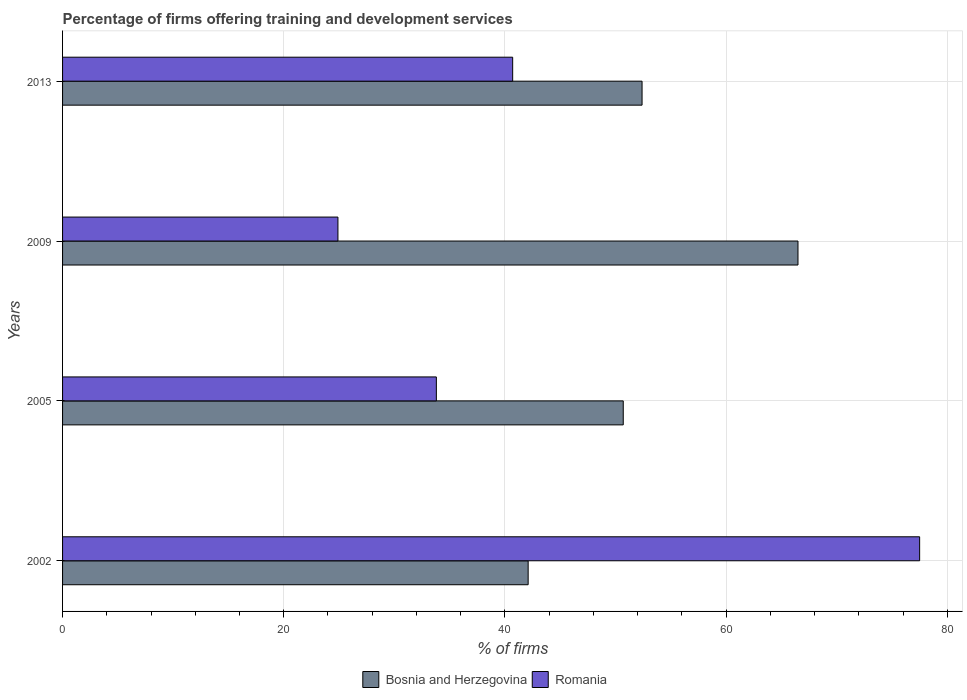Are the number of bars per tick equal to the number of legend labels?
Provide a succinct answer. Yes. Are the number of bars on each tick of the Y-axis equal?
Ensure brevity in your answer.  Yes. What is the label of the 4th group of bars from the top?
Keep it short and to the point. 2002. What is the percentage of firms offering training and development in Romania in 2005?
Your answer should be very brief. 33.8. Across all years, what is the maximum percentage of firms offering training and development in Bosnia and Herzegovina?
Provide a succinct answer. 66.5. Across all years, what is the minimum percentage of firms offering training and development in Bosnia and Herzegovina?
Your answer should be compact. 42.1. What is the total percentage of firms offering training and development in Romania in the graph?
Your answer should be very brief. 176.9. What is the difference between the percentage of firms offering training and development in Bosnia and Herzegovina in 2002 and that in 2013?
Offer a very short reply. -10.3. What is the difference between the percentage of firms offering training and development in Bosnia and Herzegovina in 2009 and the percentage of firms offering training and development in Romania in 2013?
Ensure brevity in your answer.  25.8. What is the average percentage of firms offering training and development in Romania per year?
Ensure brevity in your answer.  44.22. In the year 2002, what is the difference between the percentage of firms offering training and development in Bosnia and Herzegovina and percentage of firms offering training and development in Romania?
Your response must be concise. -35.4. In how many years, is the percentage of firms offering training and development in Romania greater than 56 %?
Ensure brevity in your answer.  1. What is the ratio of the percentage of firms offering training and development in Romania in 2009 to that in 2013?
Offer a terse response. 0.61. Is the percentage of firms offering training and development in Romania in 2009 less than that in 2013?
Provide a succinct answer. Yes. Is the difference between the percentage of firms offering training and development in Bosnia and Herzegovina in 2002 and 2009 greater than the difference between the percentage of firms offering training and development in Romania in 2002 and 2009?
Your response must be concise. No. What is the difference between the highest and the second highest percentage of firms offering training and development in Romania?
Give a very brief answer. 36.8. What is the difference between the highest and the lowest percentage of firms offering training and development in Romania?
Keep it short and to the point. 52.6. Is the sum of the percentage of firms offering training and development in Romania in 2005 and 2013 greater than the maximum percentage of firms offering training and development in Bosnia and Herzegovina across all years?
Make the answer very short. Yes. What does the 1st bar from the top in 2009 represents?
Give a very brief answer. Romania. What does the 1st bar from the bottom in 2009 represents?
Keep it short and to the point. Bosnia and Herzegovina. How many bars are there?
Provide a succinct answer. 8. How many years are there in the graph?
Provide a succinct answer. 4. Are the values on the major ticks of X-axis written in scientific E-notation?
Ensure brevity in your answer.  No. Where does the legend appear in the graph?
Provide a short and direct response. Bottom center. How many legend labels are there?
Offer a terse response. 2. What is the title of the graph?
Your answer should be very brief. Percentage of firms offering training and development services. Does "Zimbabwe" appear as one of the legend labels in the graph?
Your answer should be very brief. No. What is the label or title of the X-axis?
Offer a terse response. % of firms. What is the % of firms of Bosnia and Herzegovina in 2002?
Make the answer very short. 42.1. What is the % of firms of Romania in 2002?
Provide a succinct answer. 77.5. What is the % of firms of Bosnia and Herzegovina in 2005?
Offer a very short reply. 50.7. What is the % of firms of Romania in 2005?
Provide a short and direct response. 33.8. What is the % of firms of Bosnia and Herzegovina in 2009?
Offer a very short reply. 66.5. What is the % of firms of Romania in 2009?
Give a very brief answer. 24.9. What is the % of firms in Bosnia and Herzegovina in 2013?
Provide a succinct answer. 52.4. What is the % of firms of Romania in 2013?
Your response must be concise. 40.7. Across all years, what is the maximum % of firms in Bosnia and Herzegovina?
Your answer should be compact. 66.5. Across all years, what is the maximum % of firms of Romania?
Make the answer very short. 77.5. Across all years, what is the minimum % of firms of Bosnia and Herzegovina?
Provide a short and direct response. 42.1. Across all years, what is the minimum % of firms in Romania?
Your answer should be very brief. 24.9. What is the total % of firms in Bosnia and Herzegovina in the graph?
Provide a succinct answer. 211.7. What is the total % of firms of Romania in the graph?
Make the answer very short. 176.9. What is the difference between the % of firms of Romania in 2002 and that in 2005?
Keep it short and to the point. 43.7. What is the difference between the % of firms in Bosnia and Herzegovina in 2002 and that in 2009?
Provide a succinct answer. -24.4. What is the difference between the % of firms in Romania in 2002 and that in 2009?
Your answer should be very brief. 52.6. What is the difference between the % of firms in Bosnia and Herzegovina in 2002 and that in 2013?
Offer a terse response. -10.3. What is the difference between the % of firms of Romania in 2002 and that in 2013?
Offer a very short reply. 36.8. What is the difference between the % of firms of Bosnia and Herzegovina in 2005 and that in 2009?
Make the answer very short. -15.8. What is the difference between the % of firms of Bosnia and Herzegovina in 2005 and that in 2013?
Offer a very short reply. -1.7. What is the difference between the % of firms in Romania in 2005 and that in 2013?
Offer a terse response. -6.9. What is the difference between the % of firms in Bosnia and Herzegovina in 2009 and that in 2013?
Your answer should be compact. 14.1. What is the difference between the % of firms of Romania in 2009 and that in 2013?
Offer a terse response. -15.8. What is the difference between the % of firms of Bosnia and Herzegovina in 2002 and the % of firms of Romania in 2005?
Offer a very short reply. 8.3. What is the difference between the % of firms of Bosnia and Herzegovina in 2002 and the % of firms of Romania in 2009?
Your answer should be very brief. 17.2. What is the difference between the % of firms of Bosnia and Herzegovina in 2002 and the % of firms of Romania in 2013?
Give a very brief answer. 1.4. What is the difference between the % of firms of Bosnia and Herzegovina in 2005 and the % of firms of Romania in 2009?
Your answer should be very brief. 25.8. What is the difference between the % of firms in Bosnia and Herzegovina in 2009 and the % of firms in Romania in 2013?
Your response must be concise. 25.8. What is the average % of firms in Bosnia and Herzegovina per year?
Your answer should be very brief. 52.92. What is the average % of firms in Romania per year?
Provide a short and direct response. 44.23. In the year 2002, what is the difference between the % of firms in Bosnia and Herzegovina and % of firms in Romania?
Offer a terse response. -35.4. In the year 2009, what is the difference between the % of firms of Bosnia and Herzegovina and % of firms of Romania?
Your answer should be very brief. 41.6. In the year 2013, what is the difference between the % of firms in Bosnia and Herzegovina and % of firms in Romania?
Your response must be concise. 11.7. What is the ratio of the % of firms of Bosnia and Herzegovina in 2002 to that in 2005?
Provide a succinct answer. 0.83. What is the ratio of the % of firms of Romania in 2002 to that in 2005?
Offer a very short reply. 2.29. What is the ratio of the % of firms of Bosnia and Herzegovina in 2002 to that in 2009?
Make the answer very short. 0.63. What is the ratio of the % of firms in Romania in 2002 to that in 2009?
Make the answer very short. 3.11. What is the ratio of the % of firms of Bosnia and Herzegovina in 2002 to that in 2013?
Provide a short and direct response. 0.8. What is the ratio of the % of firms in Romania in 2002 to that in 2013?
Make the answer very short. 1.9. What is the ratio of the % of firms in Bosnia and Herzegovina in 2005 to that in 2009?
Give a very brief answer. 0.76. What is the ratio of the % of firms in Romania in 2005 to that in 2009?
Provide a short and direct response. 1.36. What is the ratio of the % of firms in Bosnia and Herzegovina in 2005 to that in 2013?
Your response must be concise. 0.97. What is the ratio of the % of firms in Romania in 2005 to that in 2013?
Ensure brevity in your answer.  0.83. What is the ratio of the % of firms of Bosnia and Herzegovina in 2009 to that in 2013?
Your response must be concise. 1.27. What is the ratio of the % of firms in Romania in 2009 to that in 2013?
Your answer should be very brief. 0.61. What is the difference between the highest and the second highest % of firms in Bosnia and Herzegovina?
Ensure brevity in your answer.  14.1. What is the difference between the highest and the second highest % of firms in Romania?
Your response must be concise. 36.8. What is the difference between the highest and the lowest % of firms in Bosnia and Herzegovina?
Provide a short and direct response. 24.4. What is the difference between the highest and the lowest % of firms in Romania?
Your answer should be compact. 52.6. 